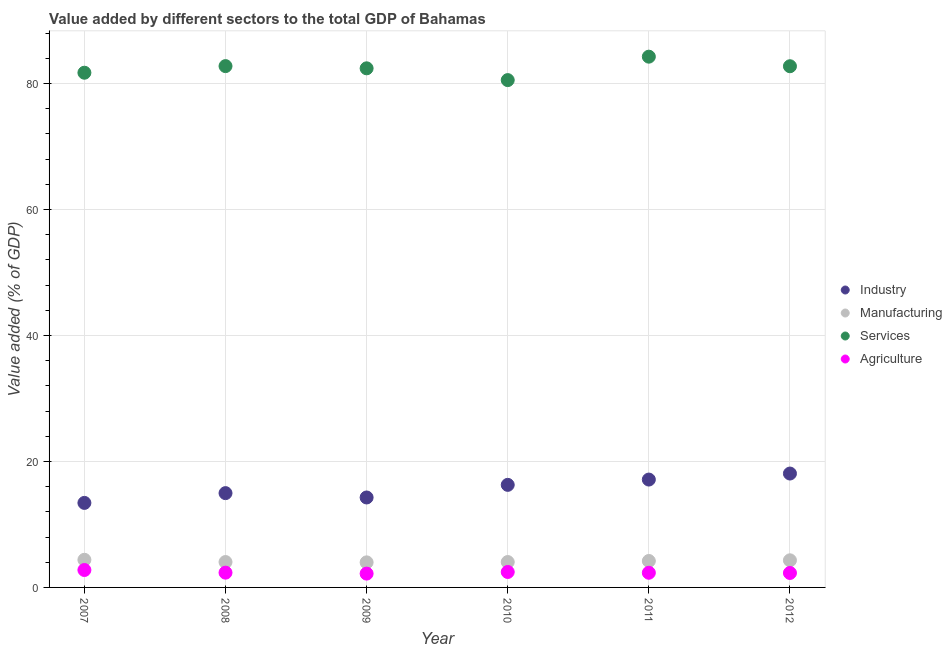How many different coloured dotlines are there?
Keep it short and to the point. 4. Is the number of dotlines equal to the number of legend labels?
Your answer should be very brief. Yes. What is the value added by agricultural sector in 2012?
Offer a very short reply. 2.29. Across all years, what is the maximum value added by manufacturing sector?
Keep it short and to the point. 4.38. Across all years, what is the minimum value added by manufacturing sector?
Your answer should be compact. 3.98. In which year was the value added by services sector minimum?
Make the answer very short. 2010. What is the total value added by manufacturing sector in the graph?
Keep it short and to the point. 24.93. What is the difference between the value added by industrial sector in 2007 and that in 2008?
Give a very brief answer. -1.55. What is the difference between the value added by manufacturing sector in 2011 and the value added by services sector in 2007?
Provide a short and direct response. -77.51. What is the average value added by agricultural sector per year?
Provide a short and direct response. 2.4. In the year 2010, what is the difference between the value added by industrial sector and value added by services sector?
Offer a terse response. -64.25. What is the ratio of the value added by industrial sector in 2008 to that in 2011?
Keep it short and to the point. 0.87. Is the value added by agricultural sector in 2007 less than that in 2008?
Give a very brief answer. No. Is the difference between the value added by agricultural sector in 2007 and 2010 greater than the difference between the value added by industrial sector in 2007 and 2010?
Your response must be concise. Yes. What is the difference between the highest and the second highest value added by agricultural sector?
Ensure brevity in your answer.  0.31. What is the difference between the highest and the lowest value added by manufacturing sector?
Your answer should be very brief. 0.41. Is the sum of the value added by services sector in 2008 and 2010 greater than the maximum value added by industrial sector across all years?
Your response must be concise. Yes. Does the value added by industrial sector monotonically increase over the years?
Ensure brevity in your answer.  No. Is the value added by services sector strictly greater than the value added by manufacturing sector over the years?
Provide a short and direct response. Yes. What is the difference between two consecutive major ticks on the Y-axis?
Keep it short and to the point. 20. Does the graph contain any zero values?
Make the answer very short. No. What is the title of the graph?
Your response must be concise. Value added by different sectors to the total GDP of Bahamas. Does "Taxes on income" appear as one of the legend labels in the graph?
Provide a succinct answer. No. What is the label or title of the Y-axis?
Provide a succinct answer. Value added (% of GDP). What is the Value added (% of GDP) of Industry in 2007?
Provide a succinct answer. 13.42. What is the Value added (% of GDP) in Manufacturing in 2007?
Ensure brevity in your answer.  4.38. What is the Value added (% of GDP) in Services in 2007?
Provide a short and direct response. 81.71. What is the Value added (% of GDP) of Agriculture in 2007?
Your answer should be very brief. 2.77. What is the Value added (% of GDP) of Industry in 2008?
Keep it short and to the point. 14.97. What is the Value added (% of GDP) of Manufacturing in 2008?
Your answer should be very brief. 4.03. What is the Value added (% of GDP) of Services in 2008?
Your response must be concise. 82.76. What is the Value added (% of GDP) of Agriculture in 2008?
Your answer should be compact. 2.34. What is the Value added (% of GDP) in Industry in 2009?
Your answer should be very brief. 14.28. What is the Value added (% of GDP) of Manufacturing in 2009?
Provide a succinct answer. 3.98. What is the Value added (% of GDP) in Services in 2009?
Offer a very short reply. 82.41. What is the Value added (% of GDP) in Agriculture in 2009?
Provide a succinct answer. 2.19. What is the Value added (% of GDP) in Industry in 2010?
Your answer should be very brief. 16.28. What is the Value added (% of GDP) of Manufacturing in 2010?
Keep it short and to the point. 4.03. What is the Value added (% of GDP) in Services in 2010?
Offer a very short reply. 80.54. What is the Value added (% of GDP) of Agriculture in 2010?
Provide a succinct answer. 2.45. What is the Value added (% of GDP) of Industry in 2011?
Your answer should be very brief. 17.12. What is the Value added (% of GDP) of Manufacturing in 2011?
Offer a terse response. 4.2. What is the Value added (% of GDP) of Services in 2011?
Provide a short and direct response. 84.26. What is the Value added (% of GDP) of Agriculture in 2011?
Provide a short and direct response. 2.33. What is the Value added (% of GDP) of Industry in 2012?
Give a very brief answer. 18.08. What is the Value added (% of GDP) of Manufacturing in 2012?
Your response must be concise. 4.3. What is the Value added (% of GDP) in Services in 2012?
Offer a very short reply. 82.74. What is the Value added (% of GDP) in Agriculture in 2012?
Provide a succinct answer. 2.29. Across all years, what is the maximum Value added (% of GDP) of Industry?
Your answer should be compact. 18.08. Across all years, what is the maximum Value added (% of GDP) of Manufacturing?
Ensure brevity in your answer.  4.38. Across all years, what is the maximum Value added (% of GDP) in Services?
Keep it short and to the point. 84.26. Across all years, what is the maximum Value added (% of GDP) in Agriculture?
Your answer should be compact. 2.77. Across all years, what is the minimum Value added (% of GDP) in Industry?
Offer a very short reply. 13.42. Across all years, what is the minimum Value added (% of GDP) of Manufacturing?
Your answer should be compact. 3.98. Across all years, what is the minimum Value added (% of GDP) of Services?
Keep it short and to the point. 80.54. Across all years, what is the minimum Value added (% of GDP) of Agriculture?
Keep it short and to the point. 2.19. What is the total Value added (% of GDP) of Industry in the graph?
Your answer should be very brief. 94.15. What is the total Value added (% of GDP) in Manufacturing in the graph?
Give a very brief answer. 24.93. What is the total Value added (% of GDP) of Services in the graph?
Keep it short and to the point. 494.4. What is the total Value added (% of GDP) in Agriculture in the graph?
Offer a very short reply. 14.37. What is the difference between the Value added (% of GDP) of Industry in 2007 and that in 2008?
Your answer should be very brief. -1.55. What is the difference between the Value added (% of GDP) in Manufacturing in 2007 and that in 2008?
Keep it short and to the point. 0.35. What is the difference between the Value added (% of GDP) of Services in 2007 and that in 2008?
Your response must be concise. -1.05. What is the difference between the Value added (% of GDP) of Agriculture in 2007 and that in 2008?
Offer a very short reply. 0.42. What is the difference between the Value added (% of GDP) of Industry in 2007 and that in 2009?
Provide a short and direct response. -0.86. What is the difference between the Value added (% of GDP) in Manufacturing in 2007 and that in 2009?
Provide a succinct answer. 0.41. What is the difference between the Value added (% of GDP) of Services in 2007 and that in 2009?
Provide a succinct answer. -0.7. What is the difference between the Value added (% of GDP) in Agriculture in 2007 and that in 2009?
Provide a succinct answer. 0.57. What is the difference between the Value added (% of GDP) of Industry in 2007 and that in 2010?
Give a very brief answer. -2.86. What is the difference between the Value added (% of GDP) of Manufacturing in 2007 and that in 2010?
Your response must be concise. 0.35. What is the difference between the Value added (% of GDP) in Services in 2007 and that in 2010?
Offer a terse response. 1.17. What is the difference between the Value added (% of GDP) in Agriculture in 2007 and that in 2010?
Make the answer very short. 0.31. What is the difference between the Value added (% of GDP) of Industry in 2007 and that in 2011?
Offer a very short reply. -3.71. What is the difference between the Value added (% of GDP) of Manufacturing in 2007 and that in 2011?
Provide a short and direct response. 0.19. What is the difference between the Value added (% of GDP) of Services in 2007 and that in 2011?
Provide a succinct answer. -2.55. What is the difference between the Value added (% of GDP) of Agriculture in 2007 and that in 2011?
Give a very brief answer. 0.44. What is the difference between the Value added (% of GDP) of Industry in 2007 and that in 2012?
Offer a very short reply. -4.66. What is the difference between the Value added (% of GDP) in Manufacturing in 2007 and that in 2012?
Offer a very short reply. 0.08. What is the difference between the Value added (% of GDP) of Services in 2007 and that in 2012?
Offer a very short reply. -1.03. What is the difference between the Value added (% of GDP) of Agriculture in 2007 and that in 2012?
Make the answer very short. 0.47. What is the difference between the Value added (% of GDP) in Industry in 2008 and that in 2009?
Offer a terse response. 0.69. What is the difference between the Value added (% of GDP) in Manufacturing in 2008 and that in 2009?
Keep it short and to the point. 0.05. What is the difference between the Value added (% of GDP) of Services in 2008 and that in 2009?
Make the answer very short. 0.35. What is the difference between the Value added (% of GDP) of Agriculture in 2008 and that in 2009?
Make the answer very short. 0.15. What is the difference between the Value added (% of GDP) in Industry in 2008 and that in 2010?
Provide a short and direct response. -1.31. What is the difference between the Value added (% of GDP) of Manufacturing in 2008 and that in 2010?
Your answer should be compact. 0. What is the difference between the Value added (% of GDP) of Services in 2008 and that in 2010?
Keep it short and to the point. 2.22. What is the difference between the Value added (% of GDP) of Agriculture in 2008 and that in 2010?
Provide a succinct answer. -0.11. What is the difference between the Value added (% of GDP) in Industry in 2008 and that in 2011?
Your answer should be compact. -2.15. What is the difference between the Value added (% of GDP) of Manufacturing in 2008 and that in 2011?
Your answer should be very brief. -0.17. What is the difference between the Value added (% of GDP) of Services in 2008 and that in 2011?
Offer a terse response. -1.5. What is the difference between the Value added (% of GDP) in Agriculture in 2008 and that in 2011?
Provide a succinct answer. 0.02. What is the difference between the Value added (% of GDP) of Industry in 2008 and that in 2012?
Make the answer very short. -3.11. What is the difference between the Value added (% of GDP) of Manufacturing in 2008 and that in 2012?
Ensure brevity in your answer.  -0.27. What is the difference between the Value added (% of GDP) in Services in 2008 and that in 2012?
Give a very brief answer. 0.02. What is the difference between the Value added (% of GDP) of Agriculture in 2008 and that in 2012?
Provide a short and direct response. 0.05. What is the difference between the Value added (% of GDP) in Industry in 2009 and that in 2010?
Offer a very short reply. -2. What is the difference between the Value added (% of GDP) in Manufacturing in 2009 and that in 2010?
Offer a very short reply. -0.05. What is the difference between the Value added (% of GDP) of Services in 2009 and that in 2010?
Your response must be concise. 1.87. What is the difference between the Value added (% of GDP) in Agriculture in 2009 and that in 2010?
Your response must be concise. -0.26. What is the difference between the Value added (% of GDP) in Industry in 2009 and that in 2011?
Keep it short and to the point. -2.84. What is the difference between the Value added (% of GDP) in Manufacturing in 2009 and that in 2011?
Provide a short and direct response. -0.22. What is the difference between the Value added (% of GDP) in Services in 2009 and that in 2011?
Keep it short and to the point. -1.85. What is the difference between the Value added (% of GDP) of Agriculture in 2009 and that in 2011?
Provide a succinct answer. -0.13. What is the difference between the Value added (% of GDP) of Industry in 2009 and that in 2012?
Provide a short and direct response. -3.8. What is the difference between the Value added (% of GDP) in Manufacturing in 2009 and that in 2012?
Keep it short and to the point. -0.32. What is the difference between the Value added (% of GDP) in Services in 2009 and that in 2012?
Make the answer very short. -0.33. What is the difference between the Value added (% of GDP) of Agriculture in 2009 and that in 2012?
Offer a very short reply. -0.1. What is the difference between the Value added (% of GDP) of Industry in 2010 and that in 2011?
Give a very brief answer. -0.84. What is the difference between the Value added (% of GDP) of Manufacturing in 2010 and that in 2011?
Provide a short and direct response. -0.17. What is the difference between the Value added (% of GDP) of Services in 2010 and that in 2011?
Provide a short and direct response. -3.72. What is the difference between the Value added (% of GDP) in Agriculture in 2010 and that in 2011?
Make the answer very short. 0.13. What is the difference between the Value added (% of GDP) of Industry in 2010 and that in 2012?
Provide a succinct answer. -1.8. What is the difference between the Value added (% of GDP) of Manufacturing in 2010 and that in 2012?
Offer a terse response. -0.27. What is the difference between the Value added (% of GDP) in Services in 2010 and that in 2012?
Your answer should be very brief. -2.2. What is the difference between the Value added (% of GDP) in Agriculture in 2010 and that in 2012?
Offer a terse response. 0.16. What is the difference between the Value added (% of GDP) in Industry in 2011 and that in 2012?
Offer a terse response. -0.96. What is the difference between the Value added (% of GDP) of Manufacturing in 2011 and that in 2012?
Your answer should be compact. -0.11. What is the difference between the Value added (% of GDP) in Services in 2011 and that in 2012?
Your response must be concise. 1.52. What is the difference between the Value added (% of GDP) of Agriculture in 2011 and that in 2012?
Provide a short and direct response. 0.03. What is the difference between the Value added (% of GDP) in Industry in 2007 and the Value added (% of GDP) in Manufacturing in 2008?
Provide a succinct answer. 9.39. What is the difference between the Value added (% of GDP) of Industry in 2007 and the Value added (% of GDP) of Services in 2008?
Offer a very short reply. -69.34. What is the difference between the Value added (% of GDP) in Industry in 2007 and the Value added (% of GDP) in Agriculture in 2008?
Your answer should be compact. 11.07. What is the difference between the Value added (% of GDP) of Manufacturing in 2007 and the Value added (% of GDP) of Services in 2008?
Provide a short and direct response. -78.37. What is the difference between the Value added (% of GDP) of Manufacturing in 2007 and the Value added (% of GDP) of Agriculture in 2008?
Your response must be concise. 2.04. What is the difference between the Value added (% of GDP) of Services in 2007 and the Value added (% of GDP) of Agriculture in 2008?
Keep it short and to the point. 79.36. What is the difference between the Value added (% of GDP) in Industry in 2007 and the Value added (% of GDP) in Manufacturing in 2009?
Keep it short and to the point. 9.44. What is the difference between the Value added (% of GDP) in Industry in 2007 and the Value added (% of GDP) in Services in 2009?
Your answer should be very brief. -68.99. What is the difference between the Value added (% of GDP) of Industry in 2007 and the Value added (% of GDP) of Agriculture in 2009?
Your answer should be compact. 11.22. What is the difference between the Value added (% of GDP) of Manufacturing in 2007 and the Value added (% of GDP) of Services in 2009?
Ensure brevity in your answer.  -78.02. What is the difference between the Value added (% of GDP) in Manufacturing in 2007 and the Value added (% of GDP) in Agriculture in 2009?
Ensure brevity in your answer.  2.19. What is the difference between the Value added (% of GDP) of Services in 2007 and the Value added (% of GDP) of Agriculture in 2009?
Your answer should be compact. 79.51. What is the difference between the Value added (% of GDP) in Industry in 2007 and the Value added (% of GDP) in Manufacturing in 2010?
Provide a short and direct response. 9.39. What is the difference between the Value added (% of GDP) of Industry in 2007 and the Value added (% of GDP) of Services in 2010?
Offer a very short reply. -67.12. What is the difference between the Value added (% of GDP) of Industry in 2007 and the Value added (% of GDP) of Agriculture in 2010?
Ensure brevity in your answer.  10.97. What is the difference between the Value added (% of GDP) of Manufacturing in 2007 and the Value added (% of GDP) of Services in 2010?
Make the answer very short. -76.15. What is the difference between the Value added (% of GDP) in Manufacturing in 2007 and the Value added (% of GDP) in Agriculture in 2010?
Offer a terse response. 1.93. What is the difference between the Value added (% of GDP) of Services in 2007 and the Value added (% of GDP) of Agriculture in 2010?
Your response must be concise. 79.26. What is the difference between the Value added (% of GDP) in Industry in 2007 and the Value added (% of GDP) in Manufacturing in 2011?
Provide a short and direct response. 9.22. What is the difference between the Value added (% of GDP) in Industry in 2007 and the Value added (% of GDP) in Services in 2011?
Provide a short and direct response. -70.84. What is the difference between the Value added (% of GDP) of Industry in 2007 and the Value added (% of GDP) of Agriculture in 2011?
Provide a short and direct response. 11.09. What is the difference between the Value added (% of GDP) in Manufacturing in 2007 and the Value added (% of GDP) in Services in 2011?
Ensure brevity in your answer.  -79.87. What is the difference between the Value added (% of GDP) in Manufacturing in 2007 and the Value added (% of GDP) in Agriculture in 2011?
Keep it short and to the point. 2.06. What is the difference between the Value added (% of GDP) in Services in 2007 and the Value added (% of GDP) in Agriculture in 2011?
Give a very brief answer. 79.38. What is the difference between the Value added (% of GDP) in Industry in 2007 and the Value added (% of GDP) in Manufacturing in 2012?
Offer a terse response. 9.11. What is the difference between the Value added (% of GDP) in Industry in 2007 and the Value added (% of GDP) in Services in 2012?
Your answer should be very brief. -69.32. What is the difference between the Value added (% of GDP) of Industry in 2007 and the Value added (% of GDP) of Agriculture in 2012?
Ensure brevity in your answer.  11.12. What is the difference between the Value added (% of GDP) in Manufacturing in 2007 and the Value added (% of GDP) in Services in 2012?
Offer a very short reply. -78.35. What is the difference between the Value added (% of GDP) in Manufacturing in 2007 and the Value added (% of GDP) in Agriculture in 2012?
Provide a short and direct response. 2.09. What is the difference between the Value added (% of GDP) in Services in 2007 and the Value added (% of GDP) in Agriculture in 2012?
Your answer should be very brief. 79.41. What is the difference between the Value added (% of GDP) of Industry in 2008 and the Value added (% of GDP) of Manufacturing in 2009?
Your response must be concise. 10.99. What is the difference between the Value added (% of GDP) of Industry in 2008 and the Value added (% of GDP) of Services in 2009?
Provide a short and direct response. -67.44. What is the difference between the Value added (% of GDP) in Industry in 2008 and the Value added (% of GDP) in Agriculture in 2009?
Provide a succinct answer. 12.78. What is the difference between the Value added (% of GDP) in Manufacturing in 2008 and the Value added (% of GDP) in Services in 2009?
Provide a short and direct response. -78.38. What is the difference between the Value added (% of GDP) in Manufacturing in 2008 and the Value added (% of GDP) in Agriculture in 2009?
Ensure brevity in your answer.  1.84. What is the difference between the Value added (% of GDP) in Services in 2008 and the Value added (% of GDP) in Agriculture in 2009?
Provide a short and direct response. 80.56. What is the difference between the Value added (% of GDP) of Industry in 2008 and the Value added (% of GDP) of Manufacturing in 2010?
Ensure brevity in your answer.  10.94. What is the difference between the Value added (% of GDP) of Industry in 2008 and the Value added (% of GDP) of Services in 2010?
Your response must be concise. -65.57. What is the difference between the Value added (% of GDP) of Industry in 2008 and the Value added (% of GDP) of Agriculture in 2010?
Your answer should be compact. 12.52. What is the difference between the Value added (% of GDP) in Manufacturing in 2008 and the Value added (% of GDP) in Services in 2010?
Your response must be concise. -76.51. What is the difference between the Value added (% of GDP) in Manufacturing in 2008 and the Value added (% of GDP) in Agriculture in 2010?
Provide a succinct answer. 1.58. What is the difference between the Value added (% of GDP) in Services in 2008 and the Value added (% of GDP) in Agriculture in 2010?
Keep it short and to the point. 80.31. What is the difference between the Value added (% of GDP) of Industry in 2008 and the Value added (% of GDP) of Manufacturing in 2011?
Provide a succinct answer. 10.77. What is the difference between the Value added (% of GDP) of Industry in 2008 and the Value added (% of GDP) of Services in 2011?
Provide a succinct answer. -69.29. What is the difference between the Value added (% of GDP) of Industry in 2008 and the Value added (% of GDP) of Agriculture in 2011?
Make the answer very short. 12.64. What is the difference between the Value added (% of GDP) in Manufacturing in 2008 and the Value added (% of GDP) in Services in 2011?
Offer a terse response. -80.22. What is the difference between the Value added (% of GDP) of Manufacturing in 2008 and the Value added (% of GDP) of Agriculture in 2011?
Ensure brevity in your answer.  1.7. What is the difference between the Value added (% of GDP) of Services in 2008 and the Value added (% of GDP) of Agriculture in 2011?
Keep it short and to the point. 80.43. What is the difference between the Value added (% of GDP) in Industry in 2008 and the Value added (% of GDP) in Manufacturing in 2012?
Your answer should be very brief. 10.66. What is the difference between the Value added (% of GDP) in Industry in 2008 and the Value added (% of GDP) in Services in 2012?
Your response must be concise. -67.77. What is the difference between the Value added (% of GDP) in Industry in 2008 and the Value added (% of GDP) in Agriculture in 2012?
Provide a succinct answer. 12.68. What is the difference between the Value added (% of GDP) of Manufacturing in 2008 and the Value added (% of GDP) of Services in 2012?
Provide a short and direct response. -78.71. What is the difference between the Value added (% of GDP) in Manufacturing in 2008 and the Value added (% of GDP) in Agriculture in 2012?
Keep it short and to the point. 1.74. What is the difference between the Value added (% of GDP) of Services in 2008 and the Value added (% of GDP) of Agriculture in 2012?
Your answer should be very brief. 80.46. What is the difference between the Value added (% of GDP) in Industry in 2009 and the Value added (% of GDP) in Manufacturing in 2010?
Keep it short and to the point. 10.25. What is the difference between the Value added (% of GDP) of Industry in 2009 and the Value added (% of GDP) of Services in 2010?
Offer a terse response. -66.26. What is the difference between the Value added (% of GDP) of Industry in 2009 and the Value added (% of GDP) of Agriculture in 2010?
Provide a succinct answer. 11.83. What is the difference between the Value added (% of GDP) in Manufacturing in 2009 and the Value added (% of GDP) in Services in 2010?
Provide a short and direct response. -76.56. What is the difference between the Value added (% of GDP) in Manufacturing in 2009 and the Value added (% of GDP) in Agriculture in 2010?
Give a very brief answer. 1.53. What is the difference between the Value added (% of GDP) of Services in 2009 and the Value added (% of GDP) of Agriculture in 2010?
Offer a terse response. 79.95. What is the difference between the Value added (% of GDP) of Industry in 2009 and the Value added (% of GDP) of Manufacturing in 2011?
Keep it short and to the point. 10.08. What is the difference between the Value added (% of GDP) in Industry in 2009 and the Value added (% of GDP) in Services in 2011?
Provide a succinct answer. -69.98. What is the difference between the Value added (% of GDP) in Industry in 2009 and the Value added (% of GDP) in Agriculture in 2011?
Ensure brevity in your answer.  11.95. What is the difference between the Value added (% of GDP) of Manufacturing in 2009 and the Value added (% of GDP) of Services in 2011?
Offer a very short reply. -80.28. What is the difference between the Value added (% of GDP) of Manufacturing in 2009 and the Value added (% of GDP) of Agriculture in 2011?
Your answer should be compact. 1.65. What is the difference between the Value added (% of GDP) in Services in 2009 and the Value added (% of GDP) in Agriculture in 2011?
Your response must be concise. 80.08. What is the difference between the Value added (% of GDP) of Industry in 2009 and the Value added (% of GDP) of Manufacturing in 2012?
Your answer should be very brief. 9.97. What is the difference between the Value added (% of GDP) in Industry in 2009 and the Value added (% of GDP) in Services in 2012?
Provide a succinct answer. -68.46. What is the difference between the Value added (% of GDP) of Industry in 2009 and the Value added (% of GDP) of Agriculture in 2012?
Your answer should be compact. 11.99. What is the difference between the Value added (% of GDP) of Manufacturing in 2009 and the Value added (% of GDP) of Services in 2012?
Your answer should be compact. -78.76. What is the difference between the Value added (% of GDP) of Manufacturing in 2009 and the Value added (% of GDP) of Agriculture in 2012?
Your response must be concise. 1.69. What is the difference between the Value added (% of GDP) in Services in 2009 and the Value added (% of GDP) in Agriculture in 2012?
Your answer should be very brief. 80.11. What is the difference between the Value added (% of GDP) of Industry in 2010 and the Value added (% of GDP) of Manufacturing in 2011?
Give a very brief answer. 12.09. What is the difference between the Value added (% of GDP) of Industry in 2010 and the Value added (% of GDP) of Services in 2011?
Give a very brief answer. -67.97. What is the difference between the Value added (% of GDP) in Industry in 2010 and the Value added (% of GDP) in Agriculture in 2011?
Offer a terse response. 13.96. What is the difference between the Value added (% of GDP) in Manufacturing in 2010 and the Value added (% of GDP) in Services in 2011?
Keep it short and to the point. -80.22. What is the difference between the Value added (% of GDP) of Manufacturing in 2010 and the Value added (% of GDP) of Agriculture in 2011?
Ensure brevity in your answer.  1.7. What is the difference between the Value added (% of GDP) of Services in 2010 and the Value added (% of GDP) of Agriculture in 2011?
Provide a short and direct response. 78.21. What is the difference between the Value added (% of GDP) of Industry in 2010 and the Value added (% of GDP) of Manufacturing in 2012?
Keep it short and to the point. 11.98. What is the difference between the Value added (% of GDP) of Industry in 2010 and the Value added (% of GDP) of Services in 2012?
Offer a terse response. -66.46. What is the difference between the Value added (% of GDP) of Industry in 2010 and the Value added (% of GDP) of Agriculture in 2012?
Your response must be concise. 13.99. What is the difference between the Value added (% of GDP) of Manufacturing in 2010 and the Value added (% of GDP) of Services in 2012?
Provide a succinct answer. -78.71. What is the difference between the Value added (% of GDP) in Manufacturing in 2010 and the Value added (% of GDP) in Agriculture in 2012?
Provide a succinct answer. 1.74. What is the difference between the Value added (% of GDP) in Services in 2010 and the Value added (% of GDP) in Agriculture in 2012?
Keep it short and to the point. 78.24. What is the difference between the Value added (% of GDP) in Industry in 2011 and the Value added (% of GDP) in Manufacturing in 2012?
Your answer should be compact. 12.82. What is the difference between the Value added (% of GDP) in Industry in 2011 and the Value added (% of GDP) in Services in 2012?
Keep it short and to the point. -65.61. What is the difference between the Value added (% of GDP) in Industry in 2011 and the Value added (% of GDP) in Agriculture in 2012?
Your answer should be very brief. 14.83. What is the difference between the Value added (% of GDP) of Manufacturing in 2011 and the Value added (% of GDP) of Services in 2012?
Offer a very short reply. -78.54. What is the difference between the Value added (% of GDP) of Manufacturing in 2011 and the Value added (% of GDP) of Agriculture in 2012?
Ensure brevity in your answer.  1.9. What is the difference between the Value added (% of GDP) in Services in 2011 and the Value added (% of GDP) in Agriculture in 2012?
Your answer should be very brief. 81.96. What is the average Value added (% of GDP) of Industry per year?
Ensure brevity in your answer.  15.69. What is the average Value added (% of GDP) of Manufacturing per year?
Ensure brevity in your answer.  4.15. What is the average Value added (% of GDP) in Services per year?
Make the answer very short. 82.4. What is the average Value added (% of GDP) in Agriculture per year?
Provide a short and direct response. 2.4. In the year 2007, what is the difference between the Value added (% of GDP) in Industry and Value added (% of GDP) in Manufacturing?
Your response must be concise. 9.03. In the year 2007, what is the difference between the Value added (% of GDP) of Industry and Value added (% of GDP) of Services?
Provide a short and direct response. -68.29. In the year 2007, what is the difference between the Value added (% of GDP) of Industry and Value added (% of GDP) of Agriculture?
Offer a very short reply. 10.65. In the year 2007, what is the difference between the Value added (% of GDP) in Manufacturing and Value added (% of GDP) in Services?
Ensure brevity in your answer.  -77.32. In the year 2007, what is the difference between the Value added (% of GDP) of Manufacturing and Value added (% of GDP) of Agriculture?
Ensure brevity in your answer.  1.62. In the year 2007, what is the difference between the Value added (% of GDP) of Services and Value added (% of GDP) of Agriculture?
Make the answer very short. 78.94. In the year 2008, what is the difference between the Value added (% of GDP) of Industry and Value added (% of GDP) of Manufacturing?
Make the answer very short. 10.94. In the year 2008, what is the difference between the Value added (% of GDP) of Industry and Value added (% of GDP) of Services?
Offer a terse response. -67.79. In the year 2008, what is the difference between the Value added (% of GDP) of Industry and Value added (% of GDP) of Agriculture?
Keep it short and to the point. 12.63. In the year 2008, what is the difference between the Value added (% of GDP) in Manufacturing and Value added (% of GDP) in Services?
Make the answer very short. -78.73. In the year 2008, what is the difference between the Value added (% of GDP) of Manufacturing and Value added (% of GDP) of Agriculture?
Make the answer very short. 1.69. In the year 2008, what is the difference between the Value added (% of GDP) of Services and Value added (% of GDP) of Agriculture?
Give a very brief answer. 80.41. In the year 2009, what is the difference between the Value added (% of GDP) of Industry and Value added (% of GDP) of Manufacturing?
Provide a succinct answer. 10.3. In the year 2009, what is the difference between the Value added (% of GDP) of Industry and Value added (% of GDP) of Services?
Offer a very short reply. -68.13. In the year 2009, what is the difference between the Value added (% of GDP) of Industry and Value added (% of GDP) of Agriculture?
Offer a terse response. 12.09. In the year 2009, what is the difference between the Value added (% of GDP) of Manufacturing and Value added (% of GDP) of Services?
Give a very brief answer. -78.43. In the year 2009, what is the difference between the Value added (% of GDP) in Manufacturing and Value added (% of GDP) in Agriculture?
Provide a succinct answer. 1.79. In the year 2009, what is the difference between the Value added (% of GDP) of Services and Value added (% of GDP) of Agriculture?
Your answer should be compact. 80.21. In the year 2010, what is the difference between the Value added (% of GDP) of Industry and Value added (% of GDP) of Manufacturing?
Offer a terse response. 12.25. In the year 2010, what is the difference between the Value added (% of GDP) in Industry and Value added (% of GDP) in Services?
Keep it short and to the point. -64.25. In the year 2010, what is the difference between the Value added (% of GDP) in Industry and Value added (% of GDP) in Agriculture?
Give a very brief answer. 13.83. In the year 2010, what is the difference between the Value added (% of GDP) of Manufacturing and Value added (% of GDP) of Services?
Give a very brief answer. -76.51. In the year 2010, what is the difference between the Value added (% of GDP) of Manufacturing and Value added (% of GDP) of Agriculture?
Provide a short and direct response. 1.58. In the year 2010, what is the difference between the Value added (% of GDP) of Services and Value added (% of GDP) of Agriculture?
Your answer should be compact. 78.08. In the year 2011, what is the difference between the Value added (% of GDP) in Industry and Value added (% of GDP) in Manufacturing?
Make the answer very short. 12.93. In the year 2011, what is the difference between the Value added (% of GDP) in Industry and Value added (% of GDP) in Services?
Provide a succinct answer. -67.13. In the year 2011, what is the difference between the Value added (% of GDP) in Industry and Value added (% of GDP) in Agriculture?
Your answer should be compact. 14.8. In the year 2011, what is the difference between the Value added (% of GDP) of Manufacturing and Value added (% of GDP) of Services?
Give a very brief answer. -80.06. In the year 2011, what is the difference between the Value added (% of GDP) in Manufacturing and Value added (% of GDP) in Agriculture?
Your response must be concise. 1.87. In the year 2011, what is the difference between the Value added (% of GDP) in Services and Value added (% of GDP) in Agriculture?
Provide a short and direct response. 81.93. In the year 2012, what is the difference between the Value added (% of GDP) of Industry and Value added (% of GDP) of Manufacturing?
Your response must be concise. 13.77. In the year 2012, what is the difference between the Value added (% of GDP) in Industry and Value added (% of GDP) in Services?
Keep it short and to the point. -64.66. In the year 2012, what is the difference between the Value added (% of GDP) in Industry and Value added (% of GDP) in Agriculture?
Provide a short and direct response. 15.79. In the year 2012, what is the difference between the Value added (% of GDP) in Manufacturing and Value added (% of GDP) in Services?
Offer a very short reply. -78.43. In the year 2012, what is the difference between the Value added (% of GDP) in Manufacturing and Value added (% of GDP) in Agriculture?
Offer a very short reply. 2.01. In the year 2012, what is the difference between the Value added (% of GDP) of Services and Value added (% of GDP) of Agriculture?
Your response must be concise. 80.44. What is the ratio of the Value added (% of GDP) in Industry in 2007 to that in 2008?
Provide a short and direct response. 0.9. What is the ratio of the Value added (% of GDP) of Manufacturing in 2007 to that in 2008?
Your response must be concise. 1.09. What is the ratio of the Value added (% of GDP) of Services in 2007 to that in 2008?
Give a very brief answer. 0.99. What is the ratio of the Value added (% of GDP) of Agriculture in 2007 to that in 2008?
Offer a terse response. 1.18. What is the ratio of the Value added (% of GDP) of Industry in 2007 to that in 2009?
Offer a very short reply. 0.94. What is the ratio of the Value added (% of GDP) in Manufacturing in 2007 to that in 2009?
Your answer should be very brief. 1.1. What is the ratio of the Value added (% of GDP) in Services in 2007 to that in 2009?
Your answer should be compact. 0.99. What is the ratio of the Value added (% of GDP) of Agriculture in 2007 to that in 2009?
Make the answer very short. 1.26. What is the ratio of the Value added (% of GDP) of Industry in 2007 to that in 2010?
Your answer should be compact. 0.82. What is the ratio of the Value added (% of GDP) of Manufacturing in 2007 to that in 2010?
Your answer should be compact. 1.09. What is the ratio of the Value added (% of GDP) of Services in 2007 to that in 2010?
Ensure brevity in your answer.  1.01. What is the ratio of the Value added (% of GDP) of Agriculture in 2007 to that in 2010?
Provide a short and direct response. 1.13. What is the ratio of the Value added (% of GDP) in Industry in 2007 to that in 2011?
Offer a very short reply. 0.78. What is the ratio of the Value added (% of GDP) in Manufacturing in 2007 to that in 2011?
Provide a short and direct response. 1.04. What is the ratio of the Value added (% of GDP) in Services in 2007 to that in 2011?
Make the answer very short. 0.97. What is the ratio of the Value added (% of GDP) in Agriculture in 2007 to that in 2011?
Keep it short and to the point. 1.19. What is the ratio of the Value added (% of GDP) of Industry in 2007 to that in 2012?
Provide a short and direct response. 0.74. What is the ratio of the Value added (% of GDP) in Manufacturing in 2007 to that in 2012?
Give a very brief answer. 1.02. What is the ratio of the Value added (% of GDP) of Services in 2007 to that in 2012?
Your answer should be compact. 0.99. What is the ratio of the Value added (% of GDP) in Agriculture in 2007 to that in 2012?
Make the answer very short. 1.21. What is the ratio of the Value added (% of GDP) of Industry in 2008 to that in 2009?
Your response must be concise. 1.05. What is the ratio of the Value added (% of GDP) of Manufacturing in 2008 to that in 2009?
Give a very brief answer. 1.01. What is the ratio of the Value added (% of GDP) in Agriculture in 2008 to that in 2009?
Offer a very short reply. 1.07. What is the ratio of the Value added (% of GDP) of Industry in 2008 to that in 2010?
Offer a terse response. 0.92. What is the ratio of the Value added (% of GDP) of Services in 2008 to that in 2010?
Offer a terse response. 1.03. What is the ratio of the Value added (% of GDP) of Agriculture in 2008 to that in 2010?
Give a very brief answer. 0.96. What is the ratio of the Value added (% of GDP) of Industry in 2008 to that in 2011?
Make the answer very short. 0.87. What is the ratio of the Value added (% of GDP) of Manufacturing in 2008 to that in 2011?
Provide a short and direct response. 0.96. What is the ratio of the Value added (% of GDP) in Services in 2008 to that in 2011?
Keep it short and to the point. 0.98. What is the ratio of the Value added (% of GDP) of Industry in 2008 to that in 2012?
Give a very brief answer. 0.83. What is the ratio of the Value added (% of GDP) of Manufacturing in 2008 to that in 2012?
Your response must be concise. 0.94. What is the ratio of the Value added (% of GDP) of Services in 2008 to that in 2012?
Offer a very short reply. 1. What is the ratio of the Value added (% of GDP) of Agriculture in 2008 to that in 2012?
Ensure brevity in your answer.  1.02. What is the ratio of the Value added (% of GDP) in Industry in 2009 to that in 2010?
Your response must be concise. 0.88. What is the ratio of the Value added (% of GDP) of Manufacturing in 2009 to that in 2010?
Keep it short and to the point. 0.99. What is the ratio of the Value added (% of GDP) of Services in 2009 to that in 2010?
Your answer should be compact. 1.02. What is the ratio of the Value added (% of GDP) in Agriculture in 2009 to that in 2010?
Make the answer very short. 0.89. What is the ratio of the Value added (% of GDP) in Industry in 2009 to that in 2011?
Your answer should be very brief. 0.83. What is the ratio of the Value added (% of GDP) of Manufacturing in 2009 to that in 2011?
Keep it short and to the point. 0.95. What is the ratio of the Value added (% of GDP) in Services in 2009 to that in 2011?
Give a very brief answer. 0.98. What is the ratio of the Value added (% of GDP) in Agriculture in 2009 to that in 2011?
Your answer should be compact. 0.94. What is the ratio of the Value added (% of GDP) in Industry in 2009 to that in 2012?
Make the answer very short. 0.79. What is the ratio of the Value added (% of GDP) of Manufacturing in 2009 to that in 2012?
Make the answer very short. 0.92. What is the ratio of the Value added (% of GDP) of Agriculture in 2009 to that in 2012?
Ensure brevity in your answer.  0.96. What is the ratio of the Value added (% of GDP) of Industry in 2010 to that in 2011?
Make the answer very short. 0.95. What is the ratio of the Value added (% of GDP) of Manufacturing in 2010 to that in 2011?
Give a very brief answer. 0.96. What is the ratio of the Value added (% of GDP) in Services in 2010 to that in 2011?
Give a very brief answer. 0.96. What is the ratio of the Value added (% of GDP) of Agriculture in 2010 to that in 2011?
Provide a short and direct response. 1.05. What is the ratio of the Value added (% of GDP) of Industry in 2010 to that in 2012?
Offer a terse response. 0.9. What is the ratio of the Value added (% of GDP) of Manufacturing in 2010 to that in 2012?
Provide a short and direct response. 0.94. What is the ratio of the Value added (% of GDP) in Services in 2010 to that in 2012?
Your answer should be compact. 0.97. What is the ratio of the Value added (% of GDP) of Agriculture in 2010 to that in 2012?
Keep it short and to the point. 1.07. What is the ratio of the Value added (% of GDP) of Industry in 2011 to that in 2012?
Your response must be concise. 0.95. What is the ratio of the Value added (% of GDP) in Manufacturing in 2011 to that in 2012?
Your response must be concise. 0.97. What is the ratio of the Value added (% of GDP) of Services in 2011 to that in 2012?
Your answer should be compact. 1.02. What is the ratio of the Value added (% of GDP) of Agriculture in 2011 to that in 2012?
Provide a short and direct response. 1.01. What is the difference between the highest and the second highest Value added (% of GDP) of Industry?
Your answer should be compact. 0.96. What is the difference between the highest and the second highest Value added (% of GDP) of Manufacturing?
Provide a succinct answer. 0.08. What is the difference between the highest and the second highest Value added (% of GDP) in Services?
Your answer should be very brief. 1.5. What is the difference between the highest and the second highest Value added (% of GDP) of Agriculture?
Offer a terse response. 0.31. What is the difference between the highest and the lowest Value added (% of GDP) in Industry?
Your answer should be compact. 4.66. What is the difference between the highest and the lowest Value added (% of GDP) of Manufacturing?
Your response must be concise. 0.41. What is the difference between the highest and the lowest Value added (% of GDP) of Services?
Your answer should be very brief. 3.72. What is the difference between the highest and the lowest Value added (% of GDP) of Agriculture?
Make the answer very short. 0.57. 